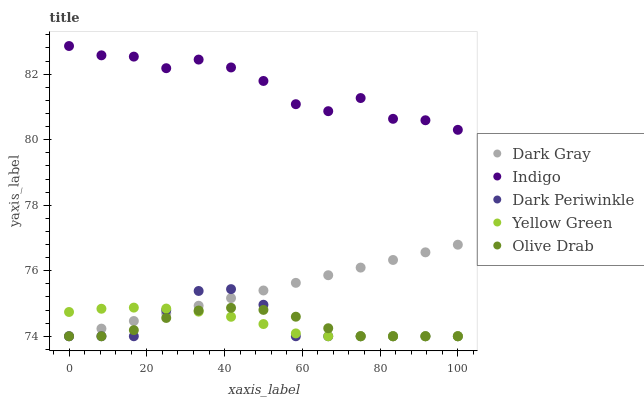Does Olive Drab have the minimum area under the curve?
Answer yes or no. Yes. Does Indigo have the maximum area under the curve?
Answer yes or no. Yes. Does Dark Periwinkle have the minimum area under the curve?
Answer yes or no. No. Does Dark Periwinkle have the maximum area under the curve?
Answer yes or no. No. Is Dark Gray the smoothest?
Answer yes or no. Yes. Is Indigo the roughest?
Answer yes or no. Yes. Is Dark Periwinkle the smoothest?
Answer yes or no. No. Is Dark Periwinkle the roughest?
Answer yes or no. No. Does Dark Gray have the lowest value?
Answer yes or no. Yes. Does Indigo have the lowest value?
Answer yes or no. No. Does Indigo have the highest value?
Answer yes or no. Yes. Does Dark Periwinkle have the highest value?
Answer yes or no. No. Is Dark Gray less than Indigo?
Answer yes or no. Yes. Is Indigo greater than Dark Gray?
Answer yes or no. Yes. Does Dark Periwinkle intersect Dark Gray?
Answer yes or no. Yes. Is Dark Periwinkle less than Dark Gray?
Answer yes or no. No. Is Dark Periwinkle greater than Dark Gray?
Answer yes or no. No. Does Dark Gray intersect Indigo?
Answer yes or no. No. 